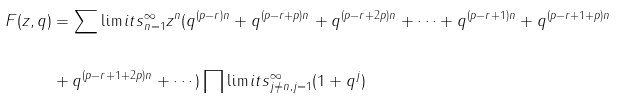Convert formula to latex. <formula><loc_0><loc_0><loc_500><loc_500>F ( z , q ) & = \sum \lim i t s _ { n = 1 } ^ { \infty } z ^ { n } ( q ^ { ( p - r ) n } + q ^ { ( p - r + p ) n } + q ^ { ( p - r + 2 p ) n } + \cdots + q ^ { ( p - r + 1 ) n } + q ^ { ( p - r + 1 + p ) n } \\ \\ & + q ^ { ( p - r + 1 + 2 p ) n } + \cdots ) \prod \lim i t s _ { j \neq n , j = 1 } ^ { \infty } ( 1 + q ^ { j } )</formula> 